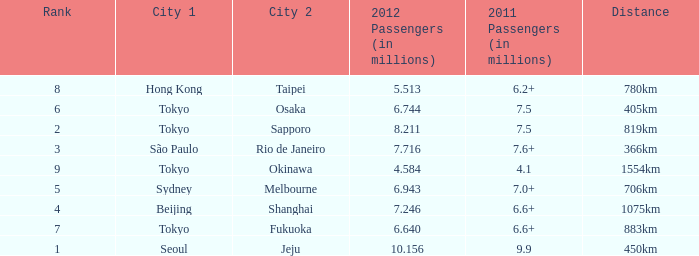How many passengers (in millions) in 2011 flew through along the route that had 6.640 million passengers in 2012? 6.6+. Could you parse the entire table? {'header': ['Rank', 'City 1', 'City 2', '2012 Passengers (in millions)', '2011 Passengers (in millions)', 'Distance'], 'rows': [['8', 'Hong Kong', 'Taipei', '5.513', '6.2+', '780km'], ['6', 'Tokyo', 'Osaka', '6.744', '7.5', '405km'], ['2', 'Tokyo', 'Sapporo', '8.211', '7.5', '819km'], ['3', 'São Paulo', 'Rio de Janeiro', '7.716', '7.6+', '366km'], ['9', 'Tokyo', 'Okinawa', '4.584', '4.1', '1554km'], ['5', 'Sydney', 'Melbourne', '6.943', '7.0+', '706km'], ['4', 'Beijing', 'Shanghai', '7.246', '6.6+', '1075km'], ['7', 'Tokyo', 'Fukuoka', '6.640', '6.6+', '883km'], ['1', 'Seoul', 'Jeju', '10.156', '9.9', '450km']]} 